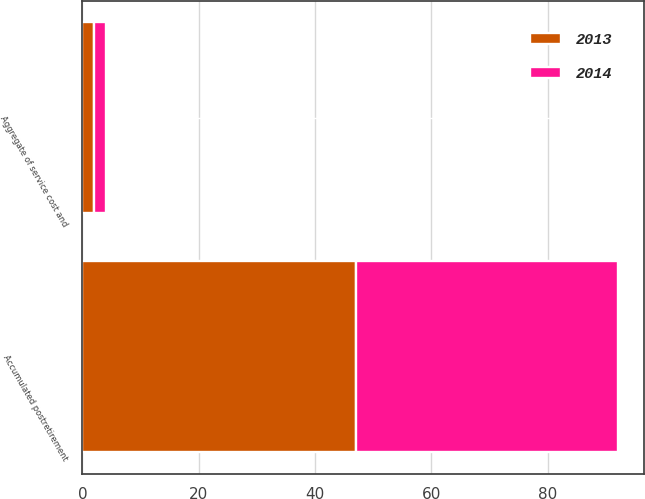Convert chart to OTSL. <chart><loc_0><loc_0><loc_500><loc_500><stacked_bar_chart><ecel><fcel>Aggregate of service cost and<fcel>Accumulated postretirement<nl><fcel>2013<fcel>2<fcel>47<nl><fcel>2014<fcel>2<fcel>45<nl></chart> 